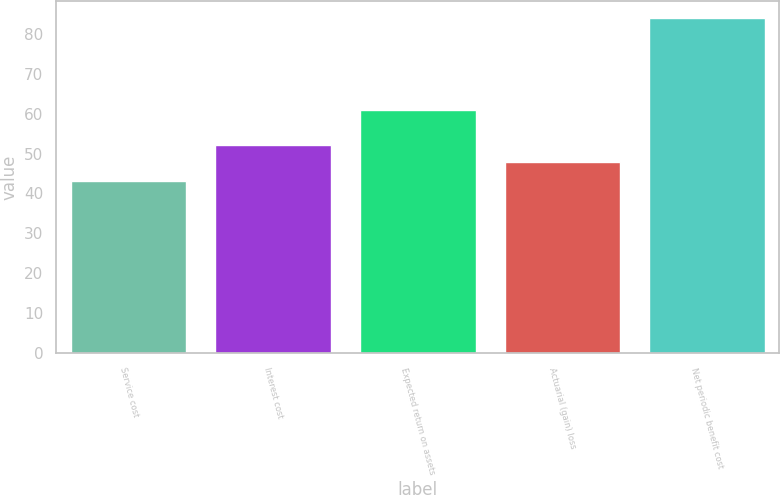Convert chart. <chart><loc_0><loc_0><loc_500><loc_500><bar_chart><fcel>Service cost<fcel>Interest cost<fcel>Expected return on assets<fcel>Actuarial (gain) loss<fcel>Net periodic benefit cost<nl><fcel>43<fcel>52.1<fcel>61<fcel>48<fcel>84<nl></chart> 